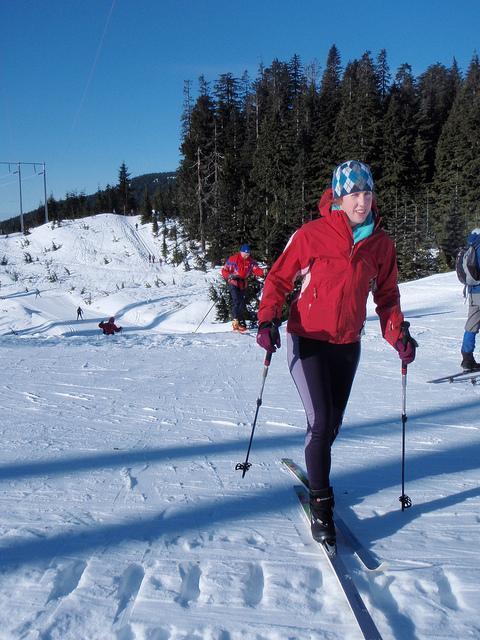How many ski are in the picture?
Give a very brief answer. 1. 